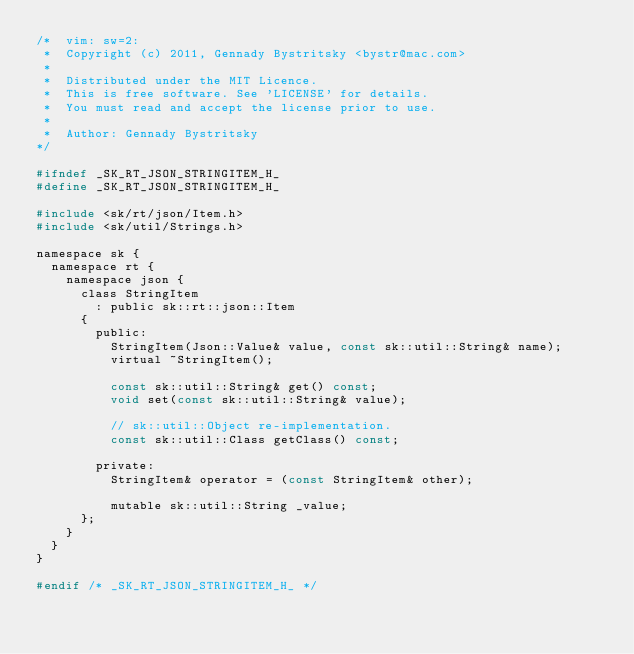<code> <loc_0><loc_0><loc_500><loc_500><_C_>/*  vim: sw=2:
 *  Copyright (c) 2011, Gennady Bystritsky <bystr@mac.com>
 *
 *  Distributed under the MIT Licence.
 *  This is free software. See 'LICENSE' for details.
 *  You must read and accept the license prior to use.
 *
 *  Author: Gennady Bystritsky
*/

#ifndef _SK_RT_JSON_STRINGITEM_H_
#define _SK_RT_JSON_STRINGITEM_H_

#include <sk/rt/json/Item.h>
#include <sk/util/Strings.h>

namespace sk {
  namespace rt {
    namespace json {
      class StringItem
        : public sk::rt::json::Item
      {
        public:
          StringItem(Json::Value& value, const sk::util::String& name);
          virtual ~StringItem();

          const sk::util::String& get() const;
          void set(const sk::util::String& value);

          // sk::util::Object re-implementation.
          const sk::util::Class getClass() const;

        private:
          StringItem& operator = (const StringItem& other);

          mutable sk::util::String _value;
      };
    }
  }
}

#endif /* _SK_RT_JSON_STRINGITEM_H_ */
</code> 